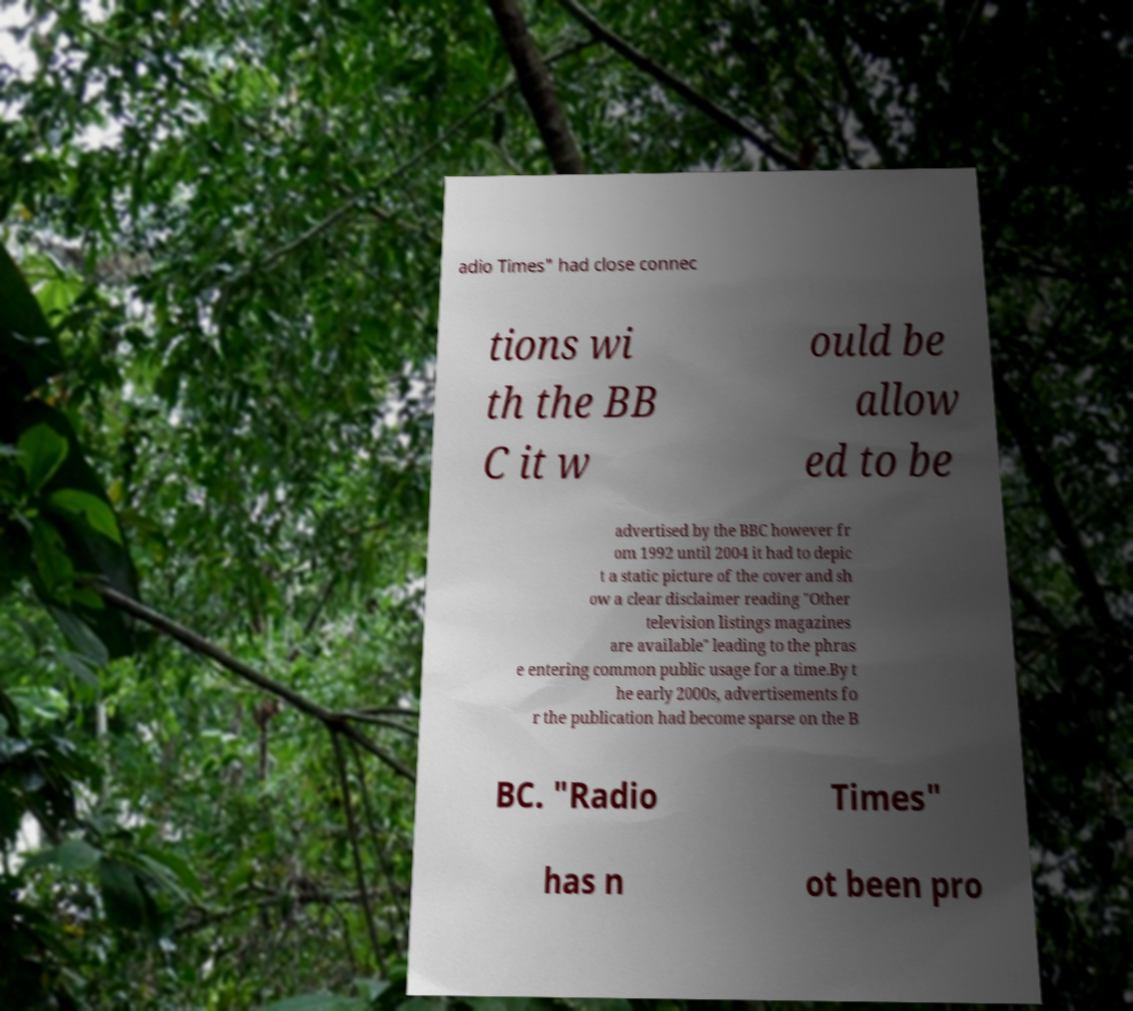Could you extract and type out the text from this image? adio Times" had close connec tions wi th the BB C it w ould be allow ed to be advertised by the BBC however fr om 1992 until 2004 it had to depic t a static picture of the cover and sh ow a clear disclaimer reading "Other television listings magazines are available" leading to the phras e entering common public usage for a time.By t he early 2000s, advertisements fo r the publication had become sparse on the B BC. "Radio Times" has n ot been pro 